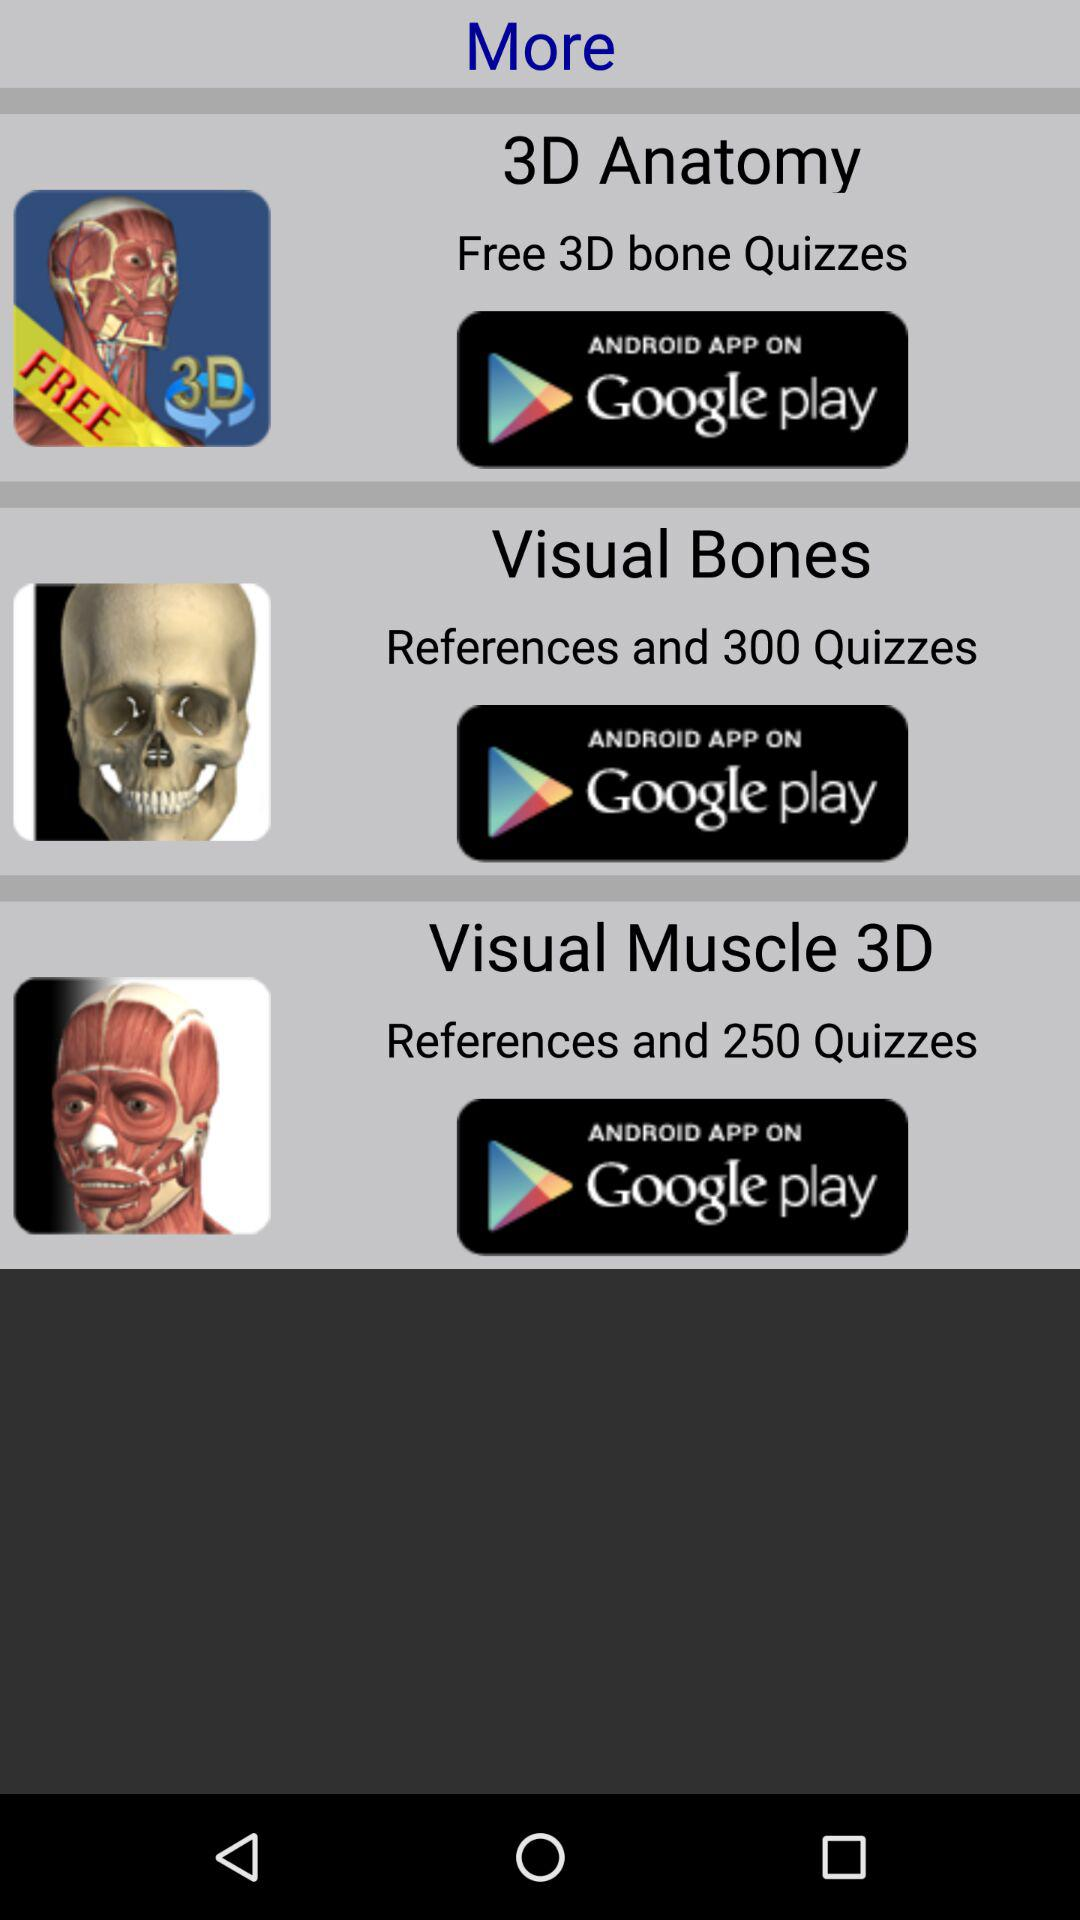How many more quizzes are available for the Visual Bones app than the Visual Muscle 3D app?
Answer the question using a single word or phrase. 50 